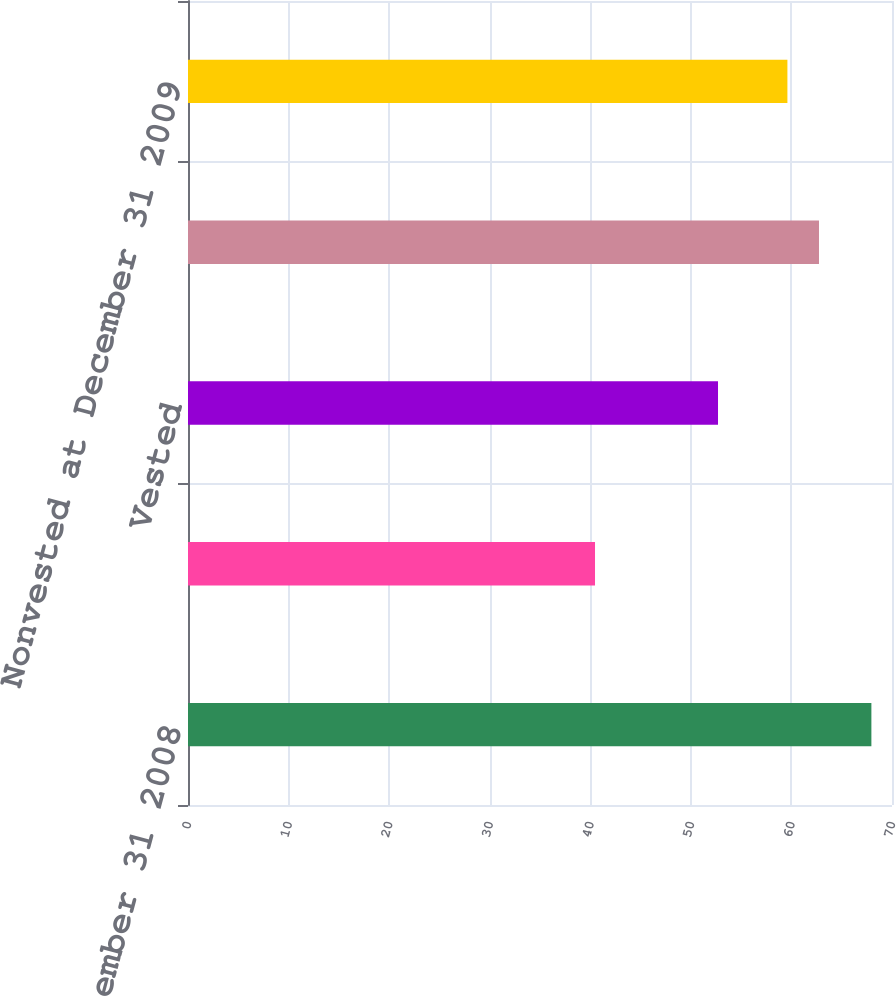Convert chart. <chart><loc_0><loc_0><loc_500><loc_500><bar_chart><fcel>Nonvested at December 31 2008<fcel>Granted<fcel>Vested<fcel>Forfeited<fcel>Nonvested at December 31 2009<nl><fcel>67.95<fcel>40.47<fcel>52.7<fcel>62.74<fcel>59.6<nl></chart> 